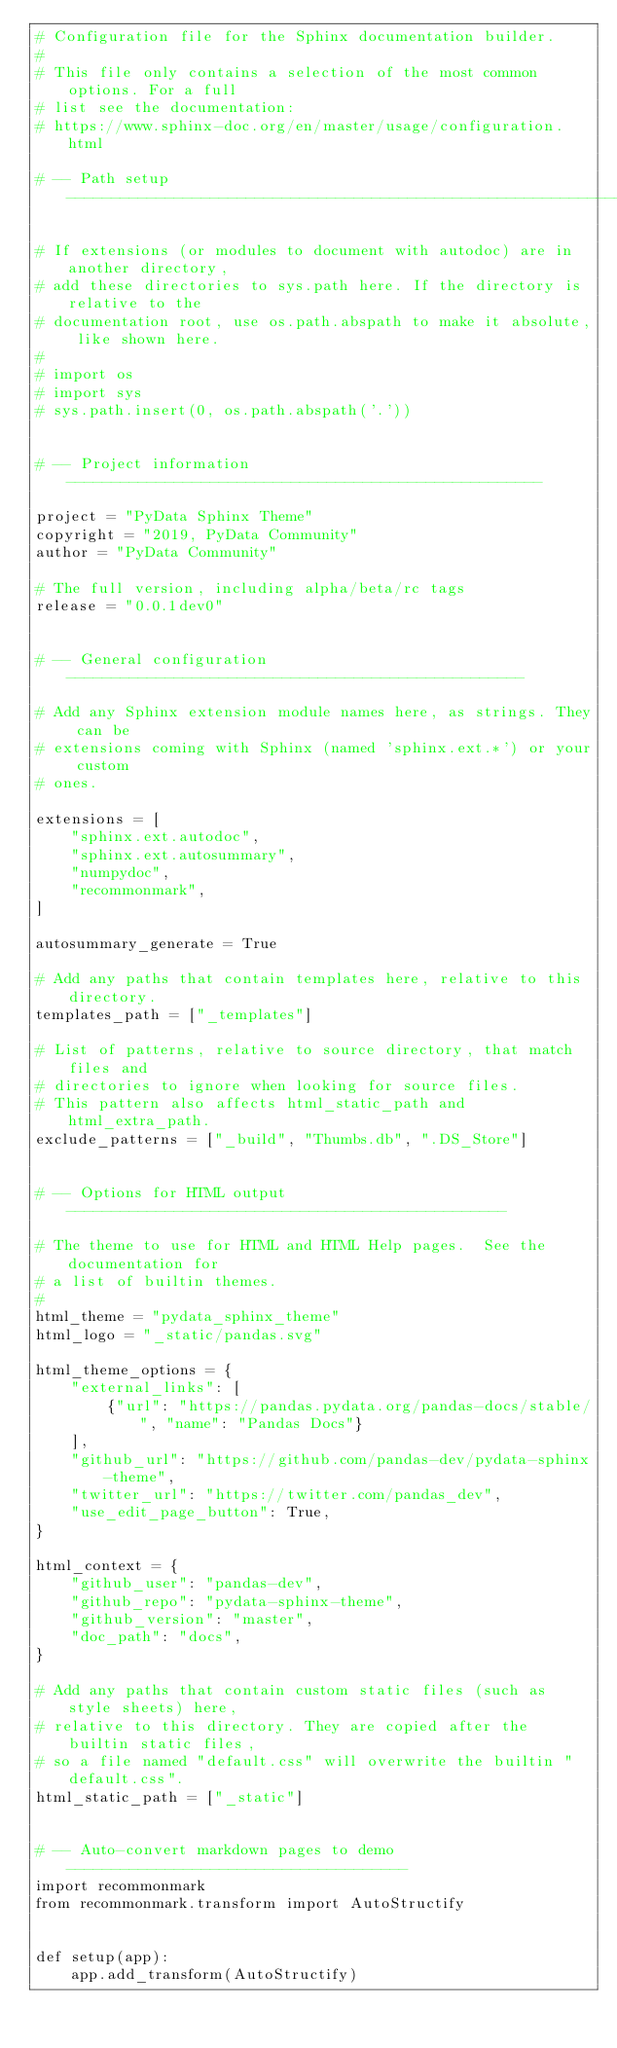Convert code to text. <code><loc_0><loc_0><loc_500><loc_500><_Python_># Configuration file for the Sphinx documentation builder.
#
# This file only contains a selection of the most common options. For a full
# list see the documentation:
# https://www.sphinx-doc.org/en/master/usage/configuration.html

# -- Path setup --------------------------------------------------------------

# If extensions (or modules to document with autodoc) are in another directory,
# add these directories to sys.path here. If the directory is relative to the
# documentation root, use os.path.abspath to make it absolute, like shown here.
#
# import os
# import sys
# sys.path.insert(0, os.path.abspath('.'))


# -- Project information -----------------------------------------------------

project = "PyData Sphinx Theme"
copyright = "2019, PyData Community"
author = "PyData Community"

# The full version, including alpha/beta/rc tags
release = "0.0.1dev0"


# -- General configuration ---------------------------------------------------

# Add any Sphinx extension module names here, as strings. They can be
# extensions coming with Sphinx (named 'sphinx.ext.*') or your custom
# ones.

extensions = [
    "sphinx.ext.autodoc",
    "sphinx.ext.autosummary",
    "numpydoc",
    "recommonmark",
]

autosummary_generate = True

# Add any paths that contain templates here, relative to this directory.
templates_path = ["_templates"]

# List of patterns, relative to source directory, that match files and
# directories to ignore when looking for source files.
# This pattern also affects html_static_path and html_extra_path.
exclude_patterns = ["_build", "Thumbs.db", ".DS_Store"]


# -- Options for HTML output -------------------------------------------------

# The theme to use for HTML and HTML Help pages.  See the documentation for
# a list of builtin themes.
#
html_theme = "pydata_sphinx_theme"
html_logo = "_static/pandas.svg"

html_theme_options = {
    "external_links": [
        {"url": "https://pandas.pydata.org/pandas-docs/stable/", "name": "Pandas Docs"}
    ],
    "github_url": "https://github.com/pandas-dev/pydata-sphinx-theme",
    "twitter_url": "https://twitter.com/pandas_dev",
    "use_edit_page_button": True,
}

html_context = {
    "github_user": "pandas-dev",
    "github_repo": "pydata-sphinx-theme",
    "github_version": "master",
    "doc_path": "docs",
}

# Add any paths that contain custom static files (such as style sheets) here,
# relative to this directory. They are copied after the builtin static files,
# so a file named "default.css" will overwrite the builtin "default.css".
html_static_path = ["_static"]


# -- Auto-convert markdown pages to demo --------------------------------------
import recommonmark
from recommonmark.transform import AutoStructify


def setup(app):
    app.add_transform(AutoStructify)
</code> 